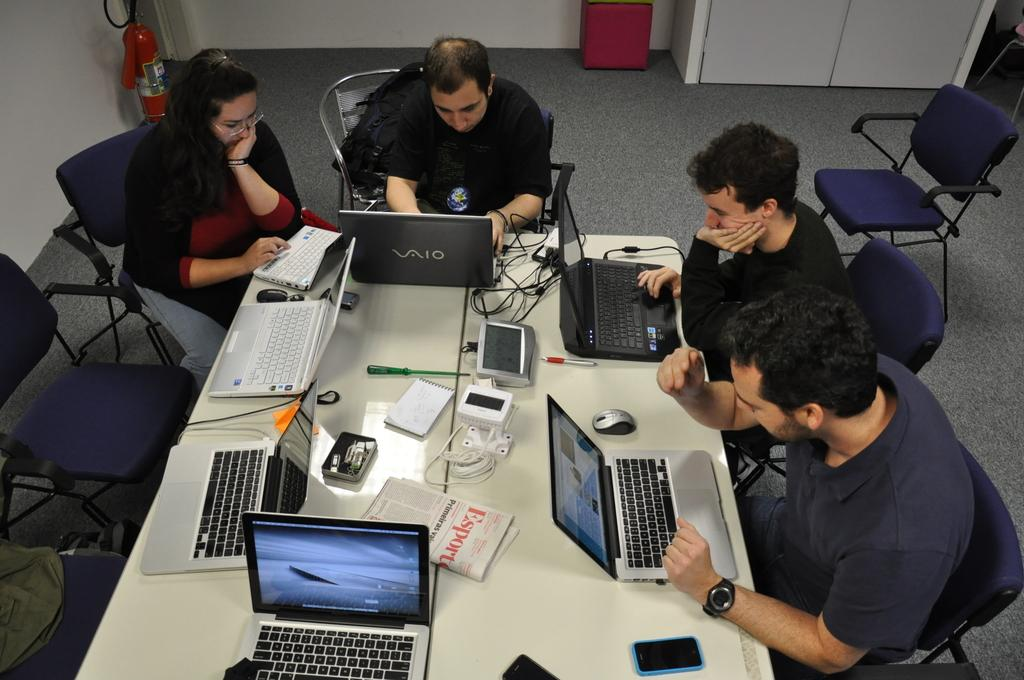<image>
Write a terse but informative summary of the picture. People at a table work on laptops, one laptop is brand named vaio. 